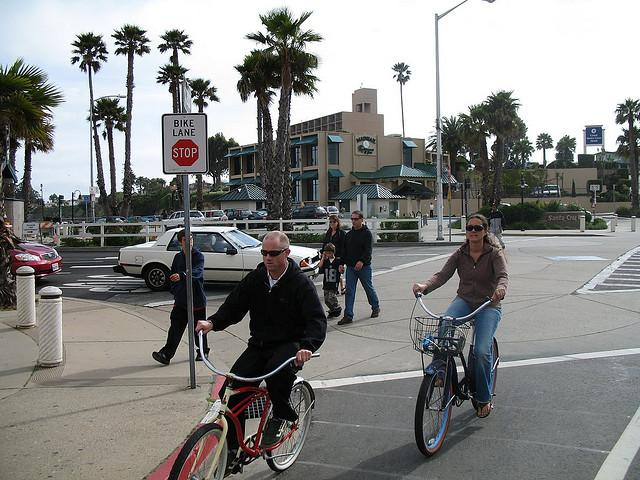What kind of sign is shown? stop 